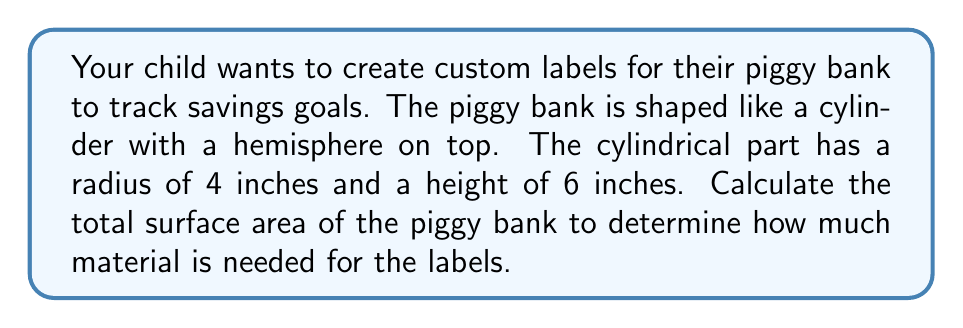Show me your answer to this math problem. Let's break this problem down into steps:

1. Calculate the surface area of the cylindrical part:
   - Lateral surface area of cylinder: $A_{lateral} = 2\pi rh$
   - Top circular area: $A_{top} = \pi r^2$
   - $A_{cylinder} = 2\pi rh + \pi r^2$

2. Calculate the surface area of the hemispherical part:
   - Surface area of hemisphere: $A_{hemisphere} = 2\pi r^2$

3. Add the two surface areas together

Step 1: Cylindrical part
$$\begin{align}
A_{cylinder} &= 2\pi rh + \pi r^2 \\
&= 2\pi(4)(6) + \pi(4)^2 \\
&= 48\pi + 16\pi \\
&= 64\pi \text{ sq inches}
\end{align}$$

Step 2: Hemispherical part
$$\begin{align}
A_{hemisphere} &= 2\pi r^2 \\
&= 2\pi(4)^2 \\
&= 32\pi \text{ sq inches}
\end{align}$$

Step 3: Total surface area
$$\begin{align}
A_{total} &= A_{cylinder} + A_{hemisphere} \\
&= 64\pi + 32\pi \\
&= 96\pi \text{ sq inches}
\end{align}$$

[asy]
import geometry;

size(200);
path p = circle((0,0),4);
path q = circle((0,6),4);
draw(p);
draw(q);
draw((4,0)--(4,6));
draw((-4,0)--(-4,6));
draw(arc((0,6),4,0,180));
label("4",(5,3),E);
label("6",(4.5,3),W);
[/asy]
Answer: The total surface area of the piggy bank is $96\pi$ square inches, or approximately 301.59 square inches. 